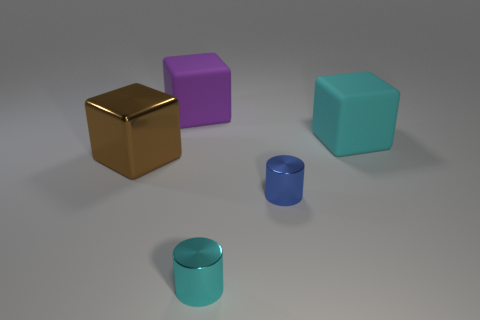Add 1 large blue spheres. How many objects exist? 6 Subtract all cylinders. How many objects are left? 3 Add 2 large brown metal objects. How many large brown metal objects exist? 3 Subtract 1 blue cylinders. How many objects are left? 4 Subtract all large cyan matte things. Subtract all small shiny cylinders. How many objects are left? 2 Add 2 small cyan objects. How many small cyan objects are left? 3 